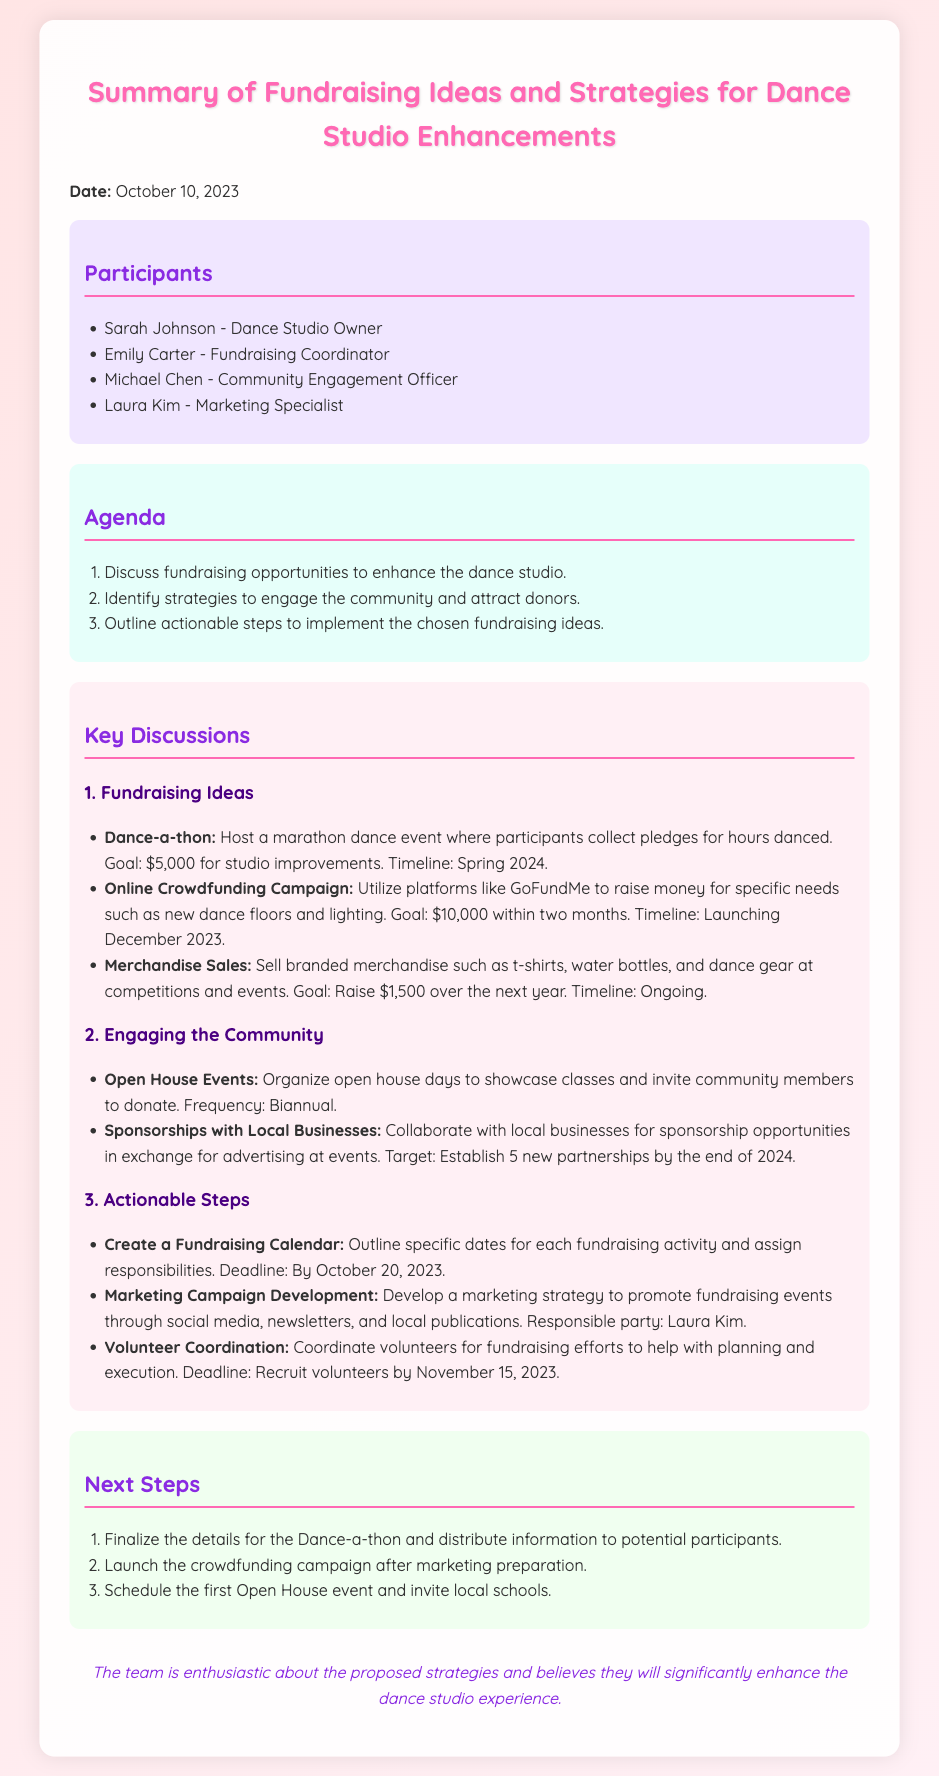What is the date of the meeting? The date is explicitly stated at the beginning of the meeting minutes.
Answer: October 10, 2023 Who is the Fundraising Coordinator? This information is listed under the participants, identifying each person's role.
Answer: Emily Carter What is the goal amount for the Dance-a-thon? The goal is mentioned alongside the fundraising idea specifically for the Dance-a-thon.
Answer: $5,000 When will the Online Crowdfunding Campaign launch? The timeline for this fundraising idea is clearly mentioned in the key discussions section.
Answer: December 2023 How many new partnerships are targeted with local businesses? The goal is outlined under engaging the community section, specifically addressing partnerships.
Answer: 5 What is the deadline for creating a fundraising calendar? The deadline for this actionable step is indicated in the key discussions section.
Answer: October 20, 2023 What is the frequency of the Open House events? This information is provided under the community engagement strategies.
Answer: Biannual Who is responsible for developing the marketing campaign? This person is assigned in the actionable steps section.
Answer: Laura Kim 